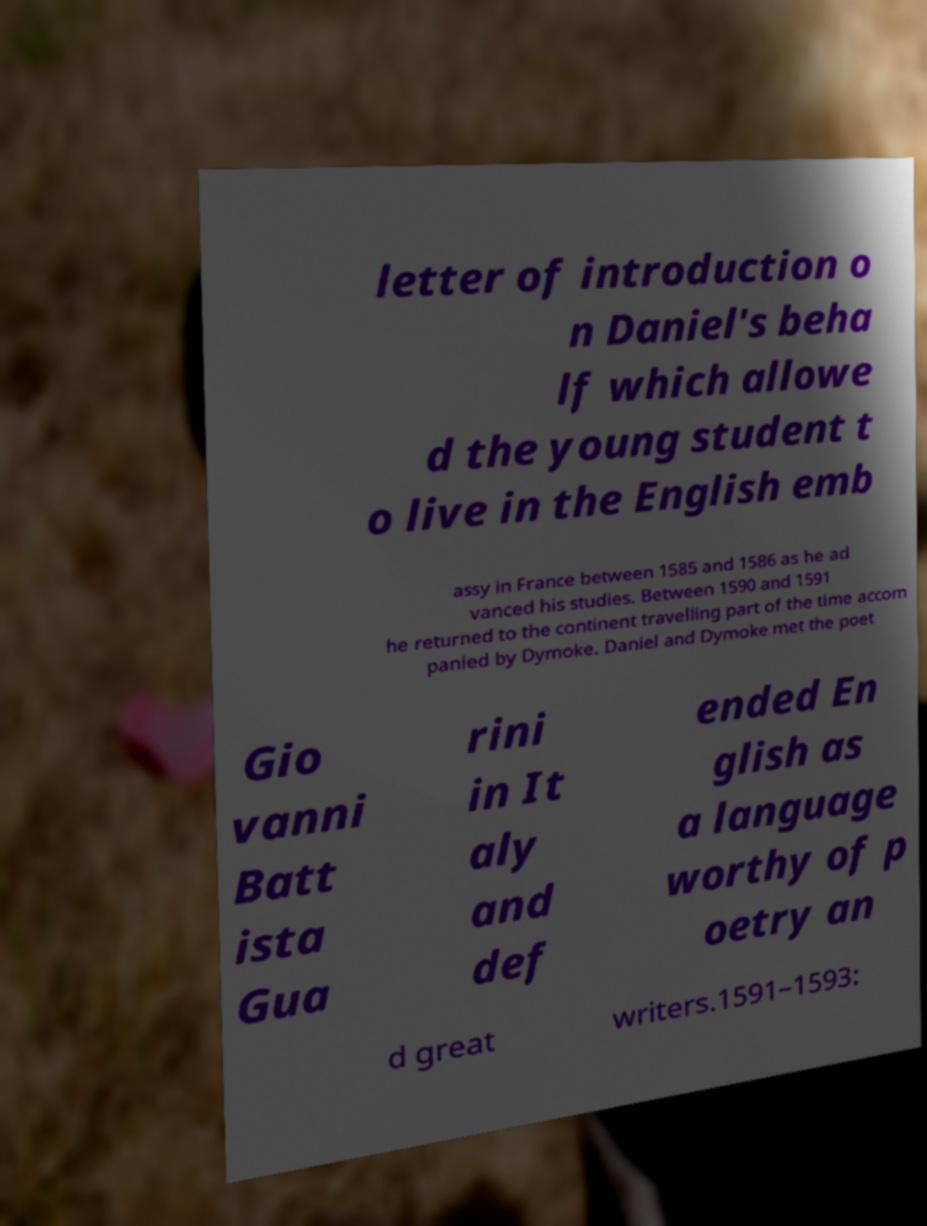There's text embedded in this image that I need extracted. Can you transcribe it verbatim? letter of introduction o n Daniel's beha lf which allowe d the young student t o live in the English emb assy in France between 1585 and 1586 as he ad vanced his studies. Between 1590 and 1591 he returned to the continent travelling part of the time accom panied by Dymoke. Daniel and Dymoke met the poet Gio vanni Batt ista Gua rini in It aly and def ended En glish as a language worthy of p oetry an d great writers.1591–1593: 